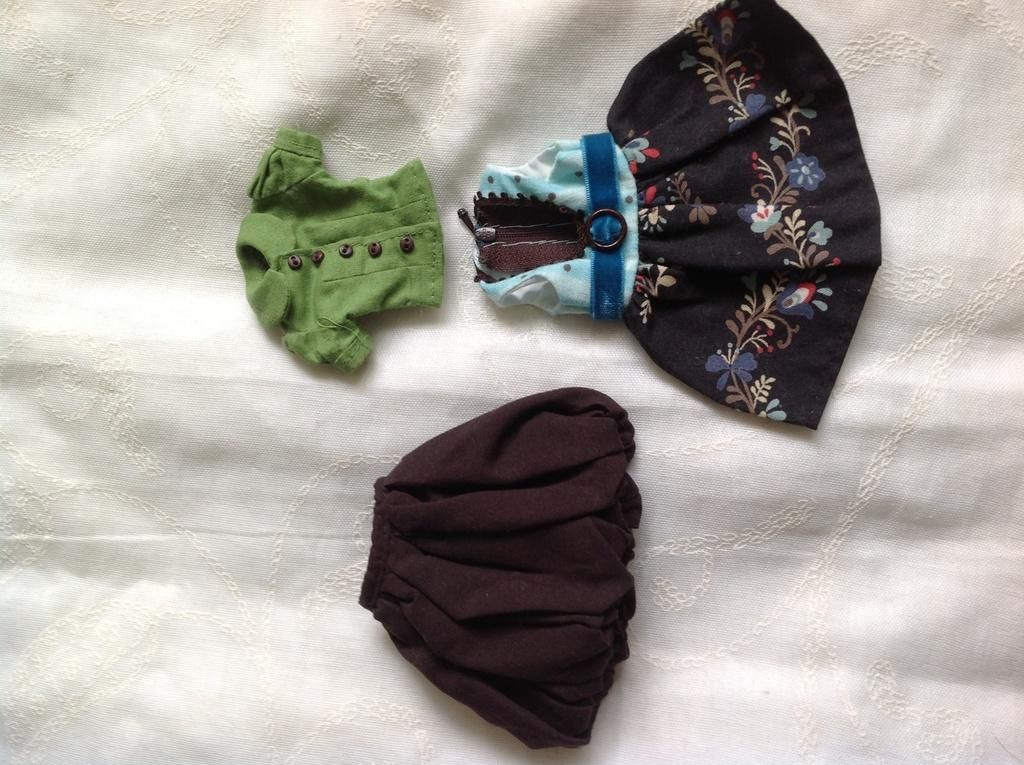What type of clothing is visible in the image? There is a frock and two shirts in the image. How are the clothes arranged in the image? The clothes are placed on a white cloth. What organization is responsible for the decision to place the dime on the shirt in the image? There is no dime or decision mentioned in the image; it only features a frock and two shirts placed on a white cloth. 